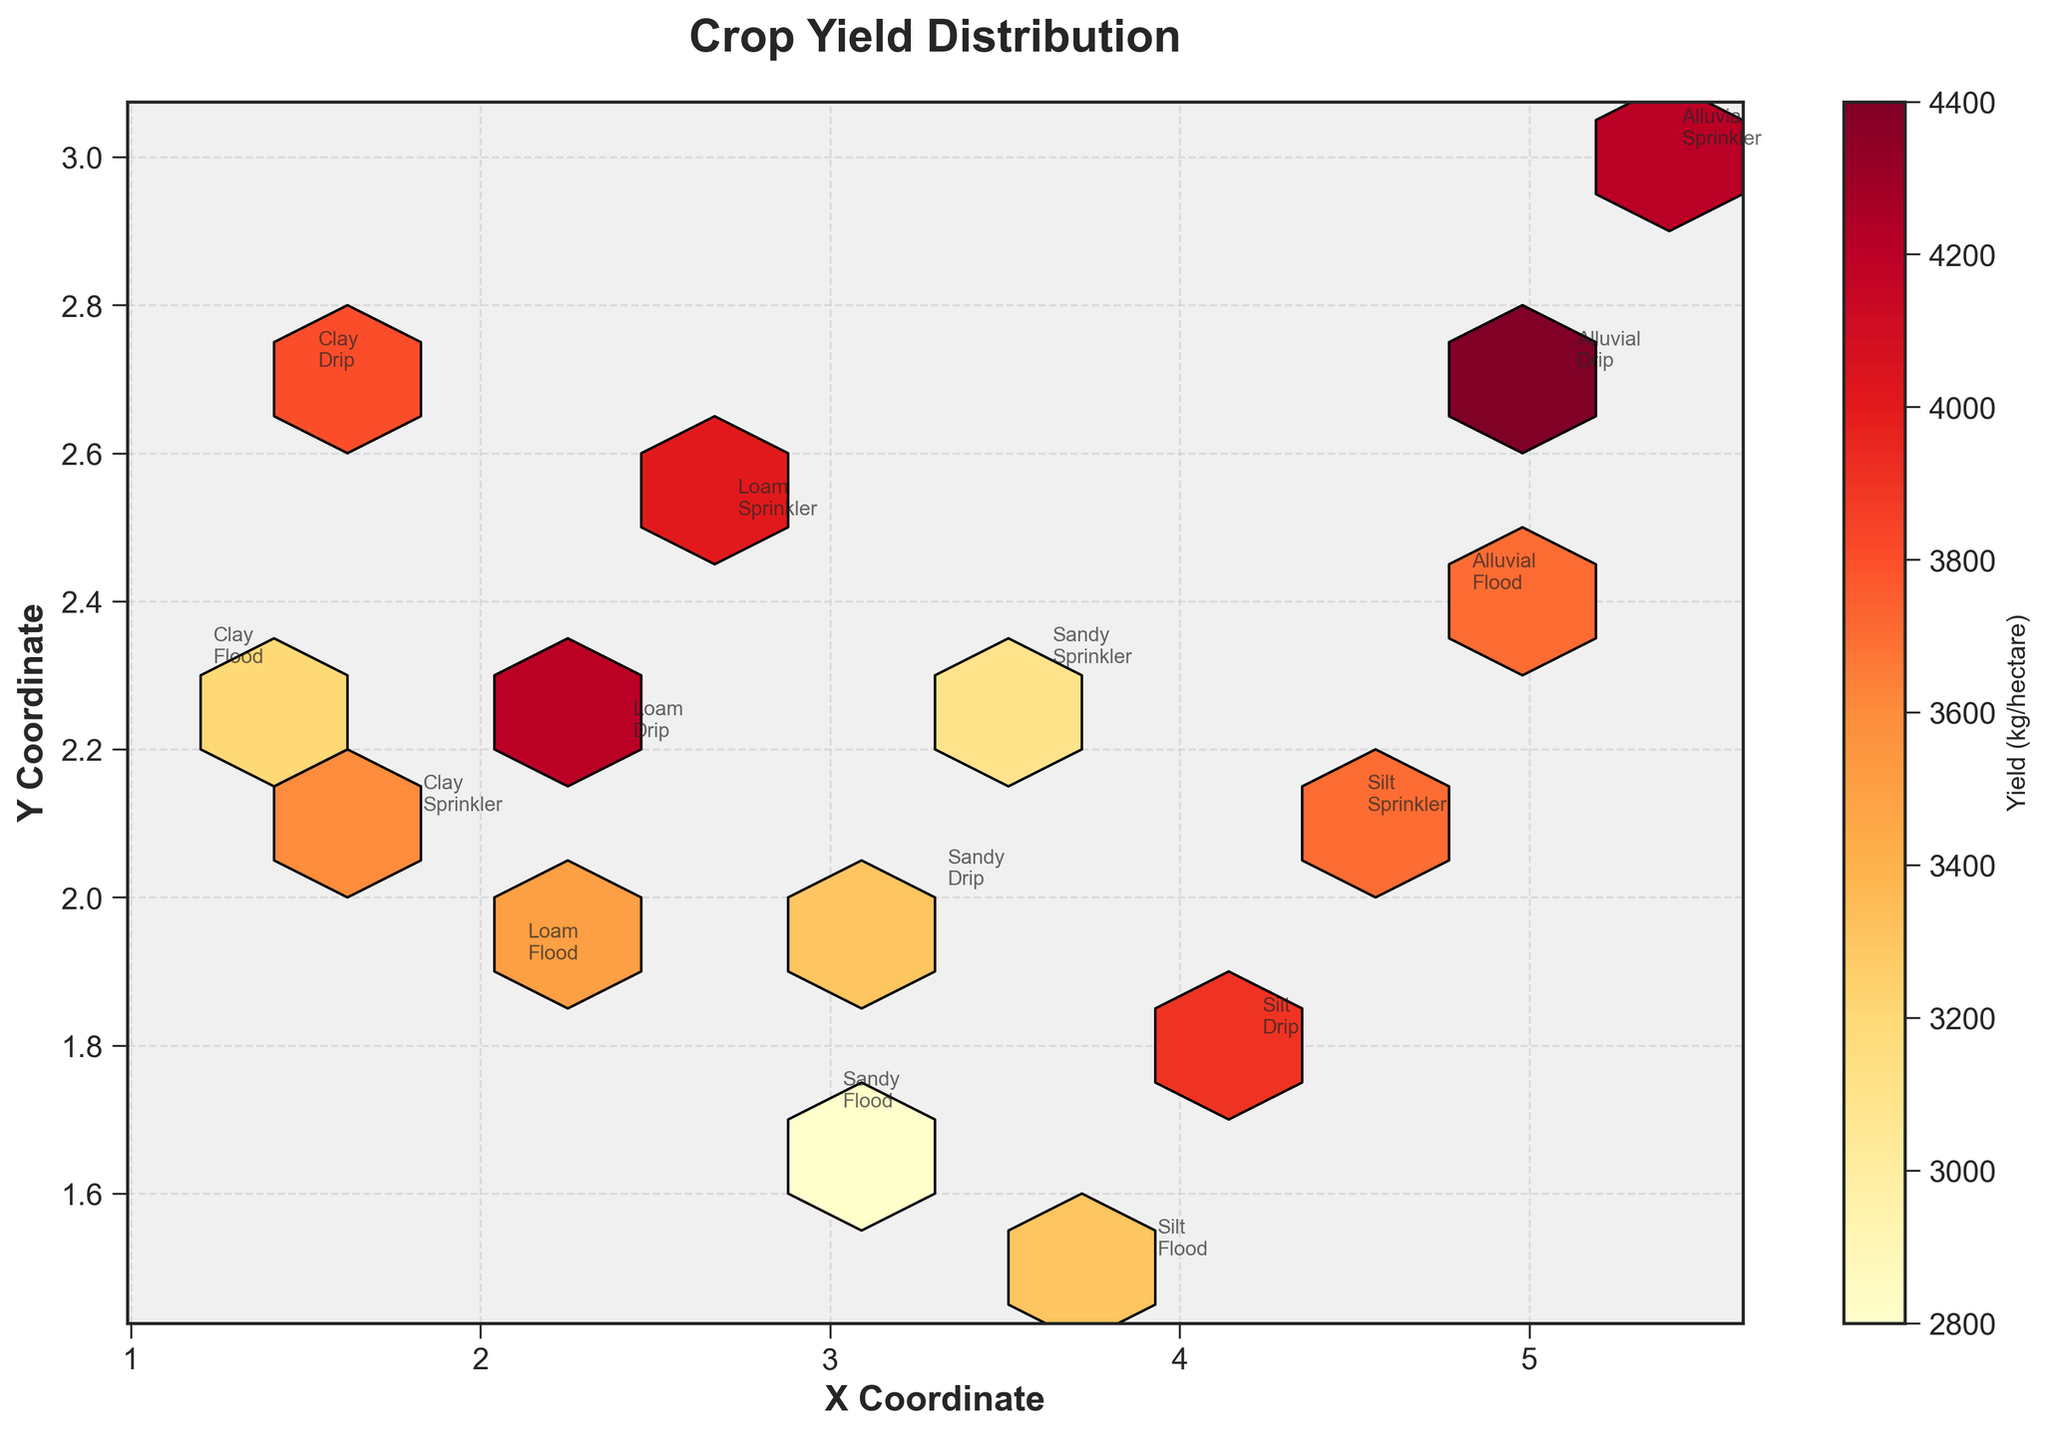What is the title of the figure? The title of the figure can be found at the top of the plot. It is usually used to describe what the figure is about.
Answer: Crop Yield Distribution What is represented by the color in the hexbin plot? The color in the hexbin plot typically represents the density or magnitude of data points within each hexagonal bin. In this figure, the color indicates the yield of crops measured in kilograms per hectare.
Answer: Yield (kg/hectare) Which soil type and irrigation method combination has the highest yield? To determine the highest yield, look at the color bar to find the darkest hexbin and then read the annotation for the soil type and irrigation method at that coordinate.
Answer: Alluvial, Drip How many different soil types are represented in the plot? Count the unique soil types listed in the annotations spread across the plot. There are five distinct soil types mentioned.
Answer: 5 What is the yield range for clay soil with different irrigation methods? To find the yield range for clay soil, identify the yield values for clay with each irrigation method from the annotations. The yields are 3200, 3800, and 3600 kg/hectare for Flood, Drip, and Sprinkler, respectively.
Answer: 3200 to 3800 kg/hectare Which soil type combined with flood irrigation has the lowest yield, and what is its value? By observing the annotations next to the points for flood irrigation, the lowest yield among the soil types with flood irrigation is for Sandy soil. The value is 2800 kg/hectare.
Answer: Sandy, 2800 kg/hectare How do the yields compare between loam soil with drip irrigation and silt soil with drip irrigation? Compare the yields indicated by the annotations. Loam with drip irrigation has a yield of 4200 kg/hectare, while silt with drip irrigation has a yield of 3900 kg/hectare.
Answer: Loam has a higher yield by 300 kg/hectare What is the average yield for alluvial soil across different irrigation methods? To calculate the average yield for alluvial soil, sum the yields (3700, 4400, 4200) and divide by the number of methods (3). (3700 + 4400 + 4200) / 3 = 12300 / 3 = 4100 kg/hectare.
Answer: 4100 kg/hectare Which irrigation method shows the most varied yield across all soil types? Examine the range of yields for each irrigation method (Flood, Drip, Sprinkler) across all annotated soil types. The drip irrigation method ranges from 3300 (Sandy) to 4400 (Alluvial), a variation of 1100 kg/hectare, which is the highest.
Answer: Drip 